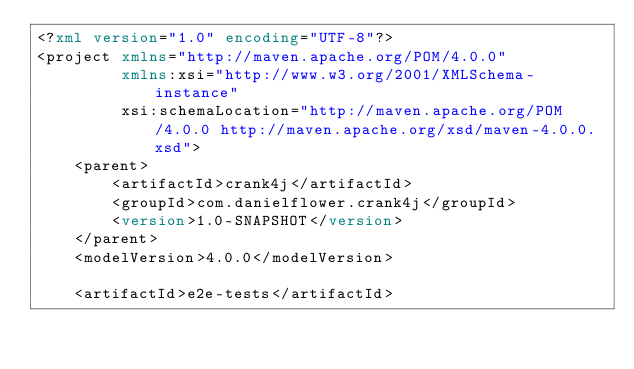<code> <loc_0><loc_0><loc_500><loc_500><_XML_><?xml version="1.0" encoding="UTF-8"?>
<project xmlns="http://maven.apache.org/POM/4.0.0"
         xmlns:xsi="http://www.w3.org/2001/XMLSchema-instance"
         xsi:schemaLocation="http://maven.apache.org/POM/4.0.0 http://maven.apache.org/xsd/maven-4.0.0.xsd">
    <parent>
        <artifactId>crank4j</artifactId>
        <groupId>com.danielflower.crank4j</groupId>
        <version>1.0-SNAPSHOT</version>
    </parent>
    <modelVersion>4.0.0</modelVersion>

    <artifactId>e2e-tests</artifactId></code> 